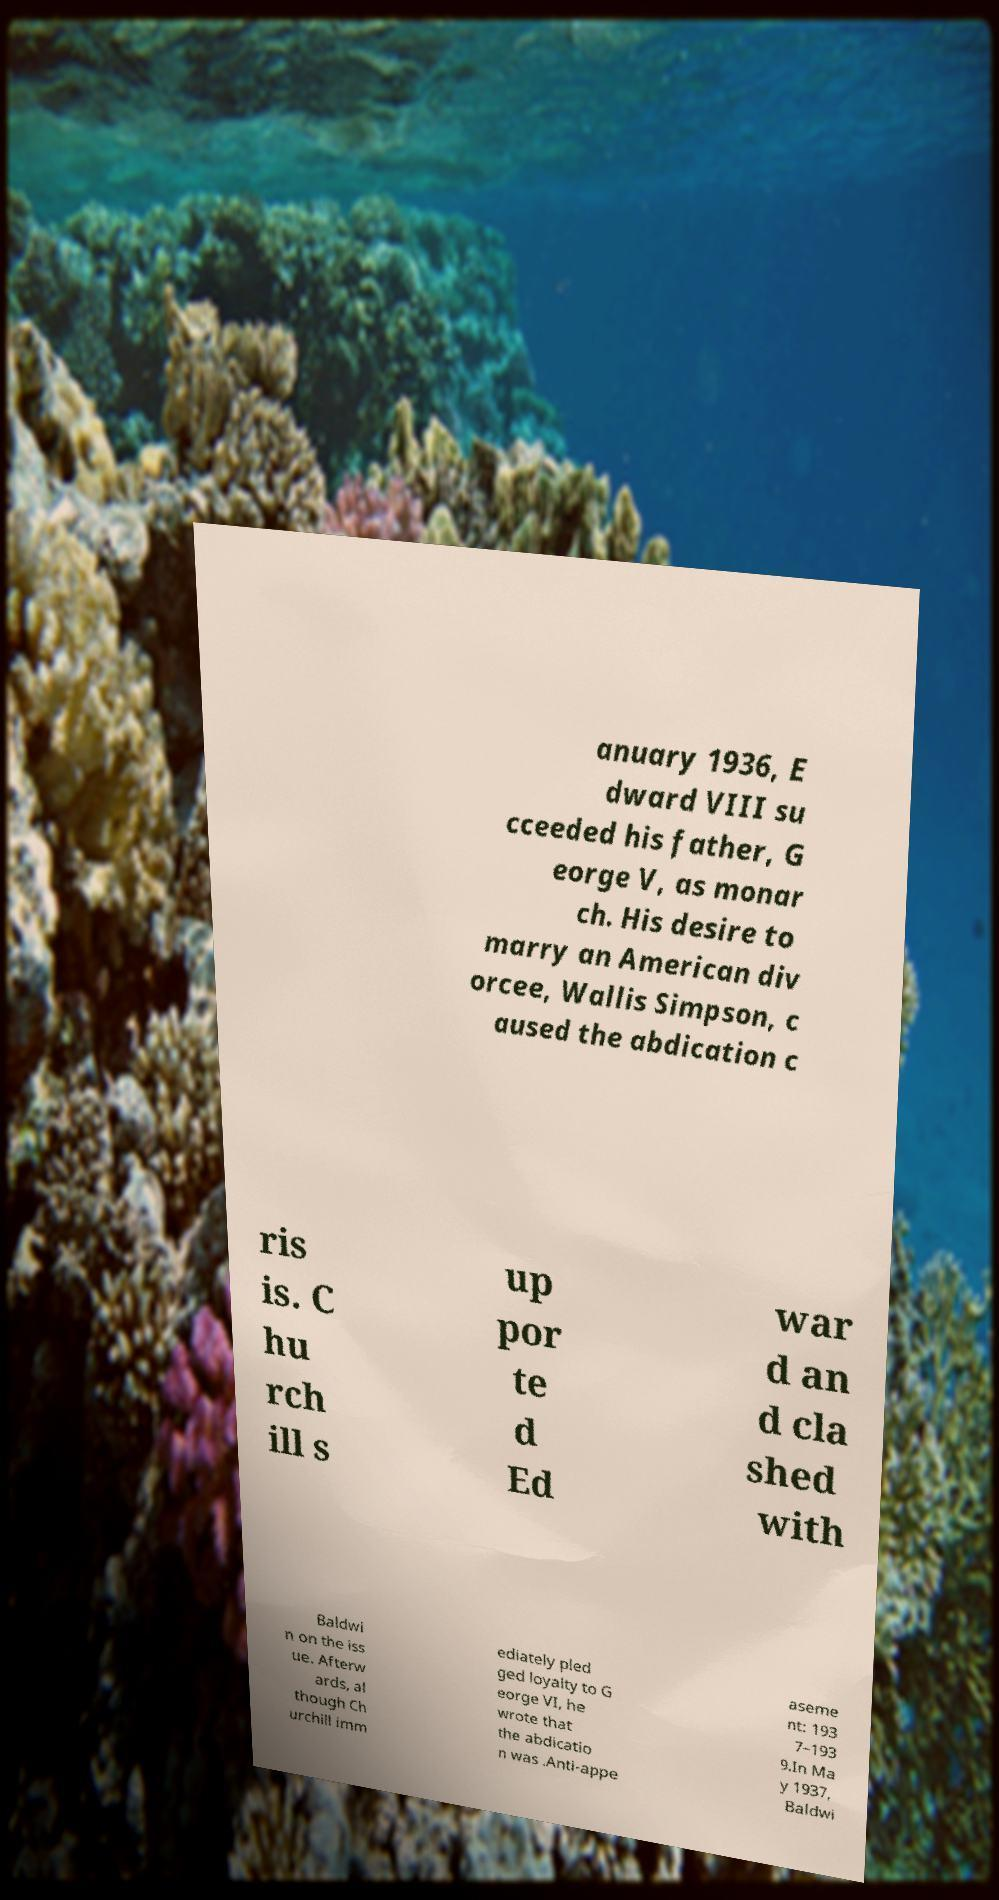Please read and relay the text visible in this image. What does it say? anuary 1936, E dward VIII su cceeded his father, G eorge V, as monar ch. His desire to marry an American div orcee, Wallis Simpson, c aused the abdication c ris is. C hu rch ill s up por te d Ed war d an d cla shed with Baldwi n on the iss ue. Afterw ards, al though Ch urchill imm ediately pled ged loyalty to G eorge VI, he wrote that the abdicatio n was .Anti-appe aseme nt: 193 7–193 9.In Ma y 1937, Baldwi 